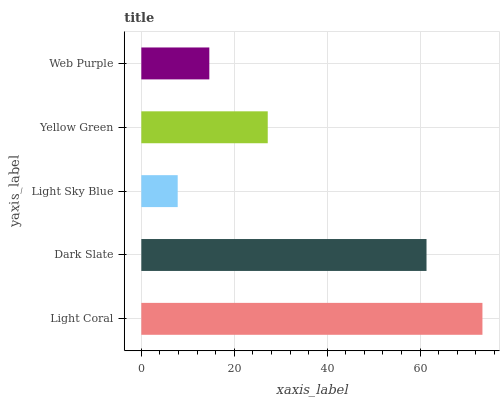Is Light Sky Blue the minimum?
Answer yes or no. Yes. Is Light Coral the maximum?
Answer yes or no. Yes. Is Dark Slate the minimum?
Answer yes or no. No. Is Dark Slate the maximum?
Answer yes or no. No. Is Light Coral greater than Dark Slate?
Answer yes or no. Yes. Is Dark Slate less than Light Coral?
Answer yes or no. Yes. Is Dark Slate greater than Light Coral?
Answer yes or no. No. Is Light Coral less than Dark Slate?
Answer yes or no. No. Is Yellow Green the high median?
Answer yes or no. Yes. Is Yellow Green the low median?
Answer yes or no. Yes. Is Light Coral the high median?
Answer yes or no. No. Is Light Coral the low median?
Answer yes or no. No. 